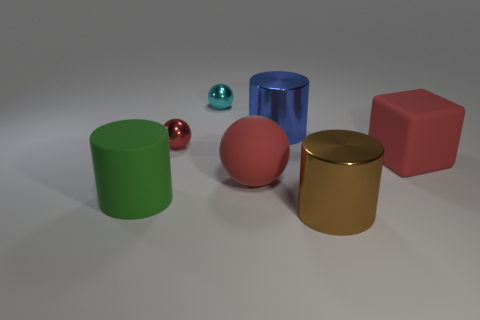There is a red ball that is the same material as the large brown cylinder; what size is it?
Make the answer very short. Small. What is the color of the ball that is behind the cylinder behind the big rubber ball?
Keep it short and to the point. Cyan. Does the big brown metal object have the same shape as the green thing left of the large blue shiny cylinder?
Provide a short and direct response. Yes. How many blue metallic objects have the same size as the red matte block?
Keep it short and to the point. 1. There is a blue thing that is the same shape as the green rubber object; what is its material?
Ensure brevity in your answer.  Metal. Does the small shiny object in front of the small cyan thing have the same color as the big cube that is right of the big blue thing?
Your response must be concise. Yes. What shape is the object that is in front of the big green object?
Offer a very short reply. Cylinder. The big cube has what color?
Make the answer very short. Red. The red object that is the same material as the cyan sphere is what shape?
Give a very brief answer. Sphere. There is a red ball that is to the right of the red metal thing; is its size the same as the cyan object?
Your answer should be compact. No. 